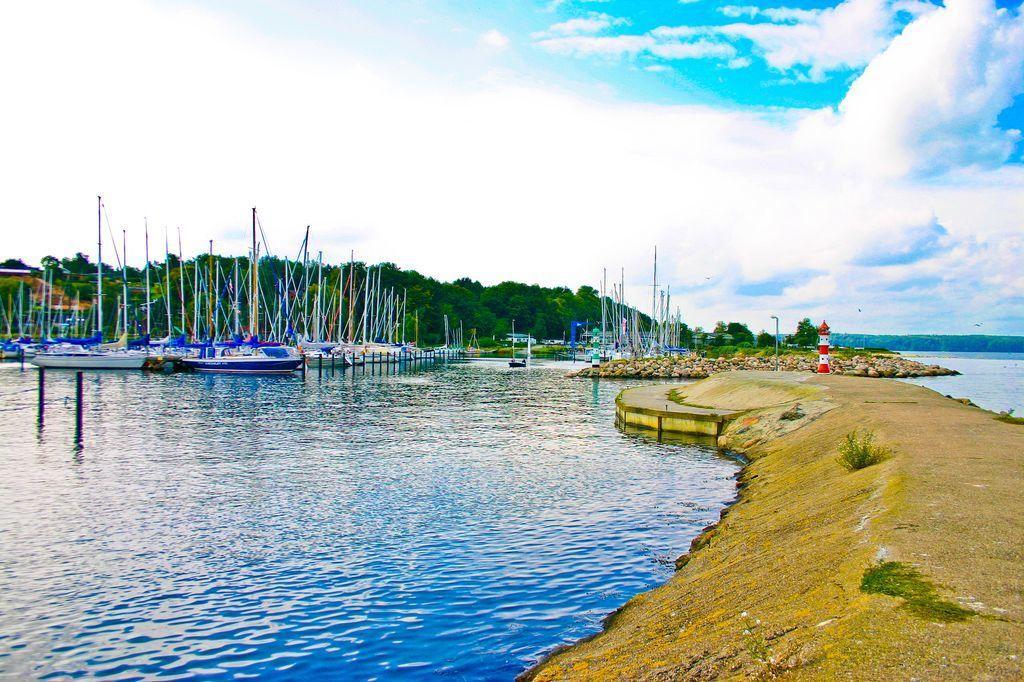Describe this image in one or two sentences. On the right side there is a path, on the left side there is a lake, on that lake there are boats, in the background there are trees and the sky. 